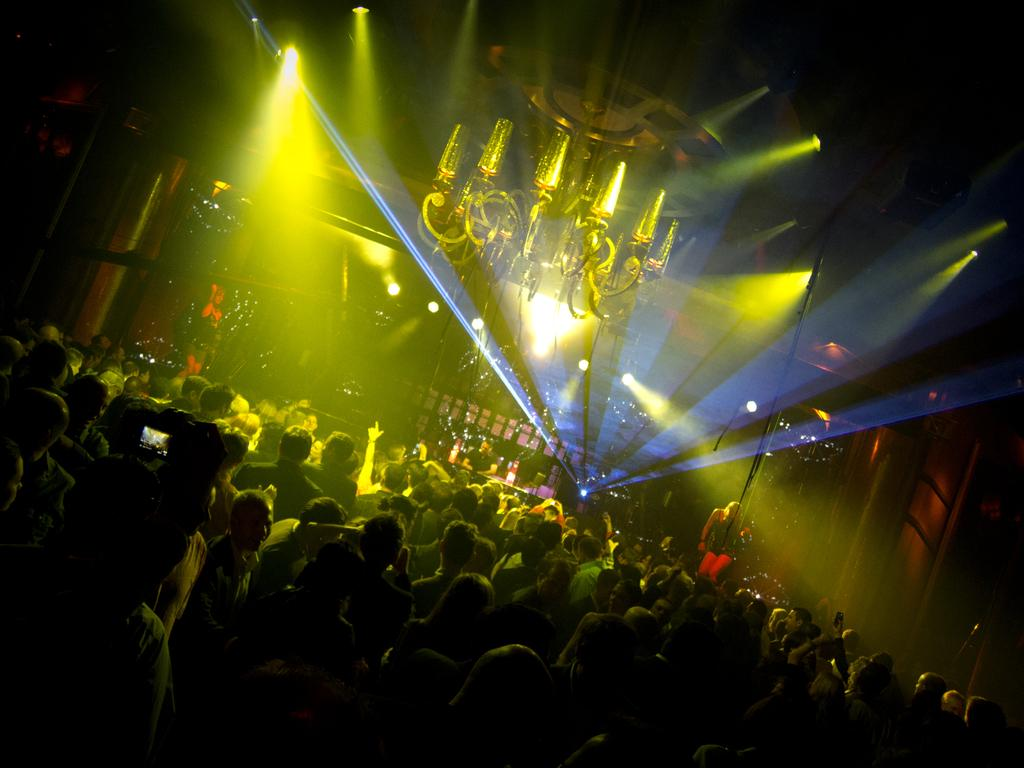What is happening in the image? There is a group of people standing in the image. Can you describe the setting of the image? There is a group of people standing on a stage in the background of the image. What can be seen in the background of the image besides the stage? There is a chandelier and focus lights present in the background of the image. What type of knee injury is visible on one of the people in the image? There is no knee injury visible on any of the people in the image. What type of spot can be seen on the stage in the image? There is no spot visible on the stage in the image. 